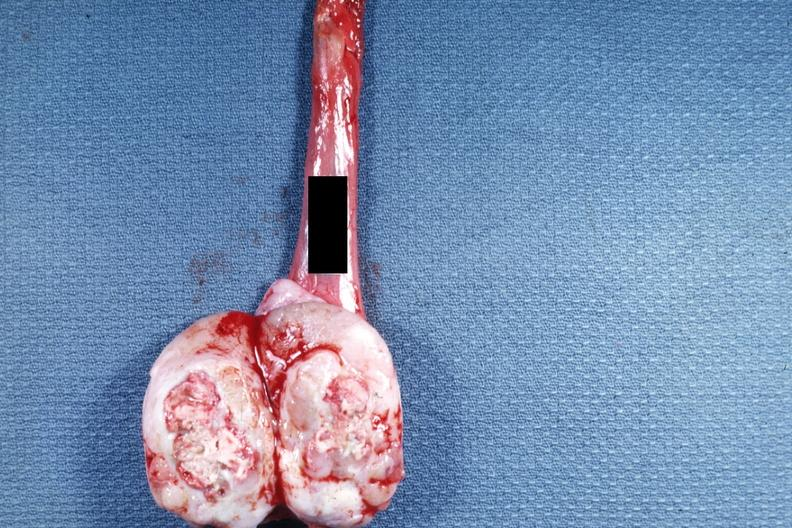what does this image show?
Answer the question using a single word or phrase. Tumor mass with a large amount of necrosis 